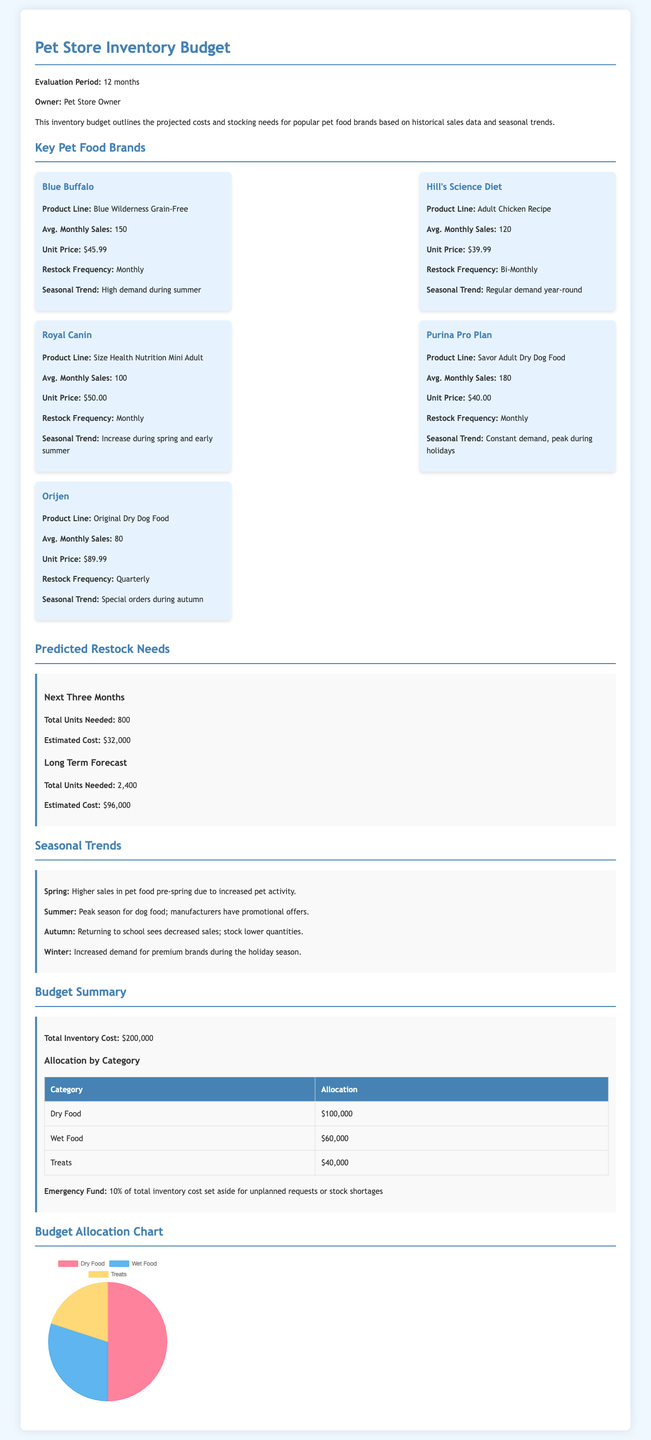What is the average monthly sales for Blue Buffalo? The average monthly sales for Blue Buffalo is provided in the document, which states it is 150 units.
Answer: 150 What is the unit price of Hill's Science Diet? The unit price for Hill's Science Diet is listed in the document as $39.99.
Answer: $39.99 What frequency is Royal Canin restocked? The document mentions the restock frequency for Royal Canin as Monthly.
Answer: Monthly What is the total inventory cost? The total inventory cost is explicitly stated in the budget summary as $200,000.
Answer: $200,000 During which season is there high demand for Blue Buffalo? The document notes that there is high demand for Blue Buffalo during summer.
Answer: Summer Which category has the highest allocation in the budget? The budget allocation clearly shows that Dry Food has the highest allocation at $100,000.
Answer: Dry Food How much is set aside for the emergency fund? The document specifies that 10% of the total inventory cost is set aside for an emergency fund, which amounts to $20,000.
Answer: $20,000 What is the seasonal trend for Purina Pro Plan? The document indicates that Purina Pro Plan has constant demand, with a peak during holidays.
Answer: Peak during holidays What is the total number of units needed for the next three months? The forecast section specifies that the total units needed for the next three months is 800.
Answer: 800 